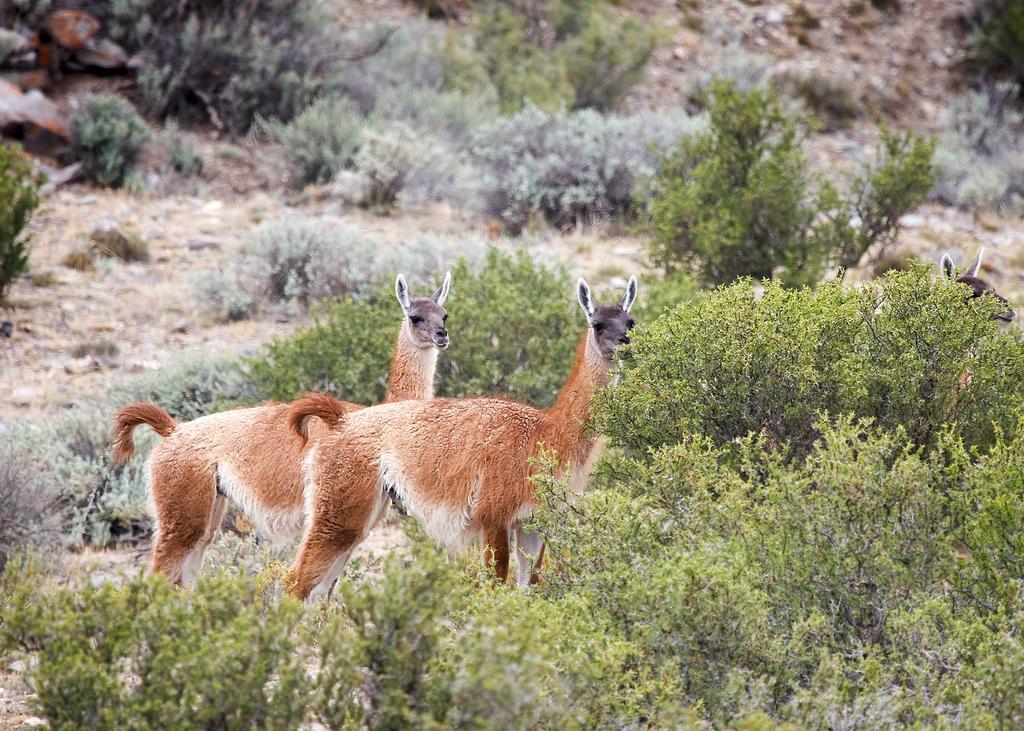How would you summarize this image in a sentence or two? In this image, I can see two animals, which are named as guanaco. These are the small bushes and the trees. I can see the face of an animal behind the tree. 